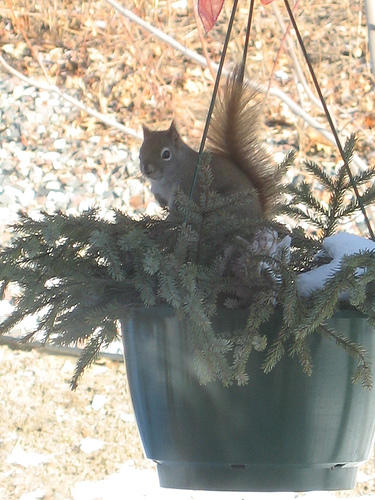<image>
Is the squirrel above the pot? Yes. The squirrel is positioned above the pot in the vertical space, higher up in the scene. 